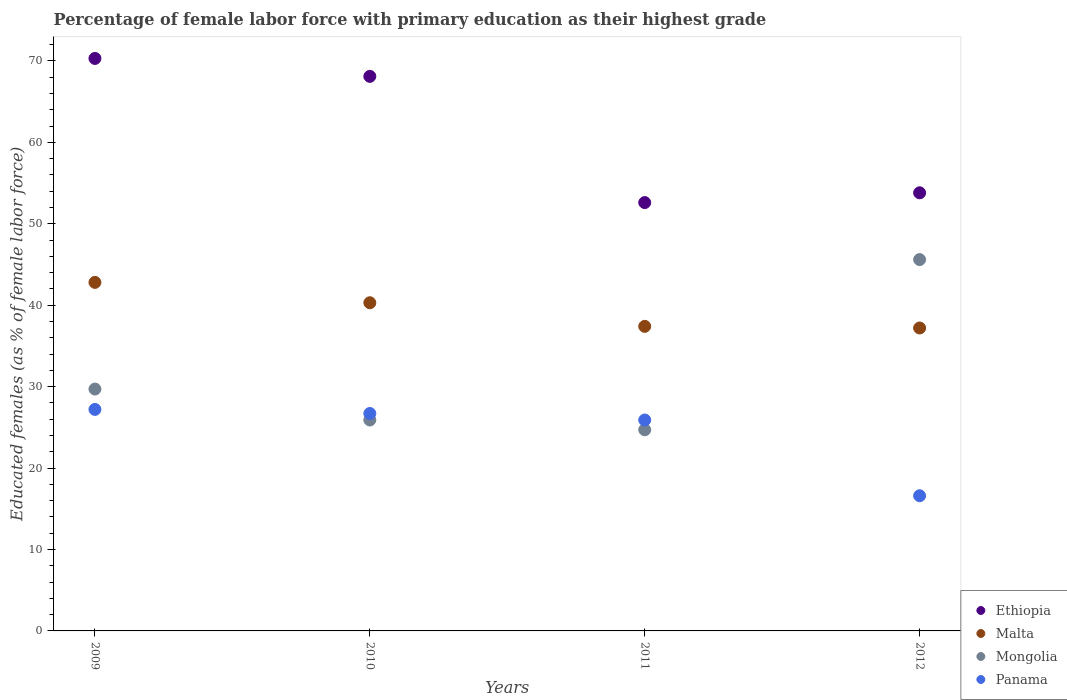What is the percentage of female labor force with primary education in Ethiopia in 2009?
Provide a succinct answer. 70.3. Across all years, what is the maximum percentage of female labor force with primary education in Panama?
Give a very brief answer. 27.2. Across all years, what is the minimum percentage of female labor force with primary education in Malta?
Keep it short and to the point. 37.2. In which year was the percentage of female labor force with primary education in Mongolia maximum?
Provide a succinct answer. 2012. What is the total percentage of female labor force with primary education in Ethiopia in the graph?
Your answer should be compact. 244.8. What is the difference between the percentage of female labor force with primary education in Malta in 2010 and that in 2011?
Your answer should be very brief. 2.9. What is the difference between the percentage of female labor force with primary education in Panama in 2011 and the percentage of female labor force with primary education in Malta in 2010?
Your answer should be very brief. -14.4. What is the average percentage of female labor force with primary education in Panama per year?
Give a very brief answer. 24.1. In the year 2011, what is the difference between the percentage of female labor force with primary education in Panama and percentage of female labor force with primary education in Ethiopia?
Offer a terse response. -26.7. In how many years, is the percentage of female labor force with primary education in Panama greater than 14 %?
Give a very brief answer. 4. What is the ratio of the percentage of female labor force with primary education in Mongolia in 2009 to that in 2011?
Your answer should be compact. 1.2. Is the percentage of female labor force with primary education in Panama in 2010 less than that in 2011?
Offer a very short reply. No. Is the difference between the percentage of female labor force with primary education in Panama in 2010 and 2012 greater than the difference between the percentage of female labor force with primary education in Ethiopia in 2010 and 2012?
Your answer should be very brief. No. What is the difference between the highest and the second highest percentage of female labor force with primary education in Ethiopia?
Offer a terse response. 2.2. What is the difference between the highest and the lowest percentage of female labor force with primary education in Panama?
Provide a short and direct response. 10.6. Is it the case that in every year, the sum of the percentage of female labor force with primary education in Mongolia and percentage of female labor force with primary education in Ethiopia  is greater than the sum of percentage of female labor force with primary education in Malta and percentage of female labor force with primary education in Panama?
Your answer should be very brief. No. Is it the case that in every year, the sum of the percentage of female labor force with primary education in Mongolia and percentage of female labor force with primary education in Panama  is greater than the percentage of female labor force with primary education in Malta?
Ensure brevity in your answer.  Yes. Does the percentage of female labor force with primary education in Panama monotonically increase over the years?
Keep it short and to the point. No. Is the percentage of female labor force with primary education in Panama strictly less than the percentage of female labor force with primary education in Mongolia over the years?
Provide a short and direct response. No. How many dotlines are there?
Your response must be concise. 4. How many years are there in the graph?
Your response must be concise. 4. Are the values on the major ticks of Y-axis written in scientific E-notation?
Your answer should be very brief. No. Does the graph contain grids?
Make the answer very short. No. How are the legend labels stacked?
Make the answer very short. Vertical. What is the title of the graph?
Make the answer very short. Percentage of female labor force with primary education as their highest grade. Does "Benin" appear as one of the legend labels in the graph?
Provide a succinct answer. No. What is the label or title of the Y-axis?
Keep it short and to the point. Educated females (as % of female labor force). What is the Educated females (as % of female labor force) in Ethiopia in 2009?
Make the answer very short. 70.3. What is the Educated females (as % of female labor force) in Malta in 2009?
Your answer should be very brief. 42.8. What is the Educated females (as % of female labor force) in Mongolia in 2009?
Keep it short and to the point. 29.7. What is the Educated females (as % of female labor force) in Panama in 2009?
Offer a terse response. 27.2. What is the Educated females (as % of female labor force) of Ethiopia in 2010?
Your response must be concise. 68.1. What is the Educated females (as % of female labor force) of Malta in 2010?
Provide a short and direct response. 40.3. What is the Educated females (as % of female labor force) of Mongolia in 2010?
Your answer should be compact. 25.9. What is the Educated females (as % of female labor force) in Panama in 2010?
Offer a very short reply. 26.7. What is the Educated females (as % of female labor force) in Ethiopia in 2011?
Offer a terse response. 52.6. What is the Educated females (as % of female labor force) of Malta in 2011?
Your response must be concise. 37.4. What is the Educated females (as % of female labor force) of Mongolia in 2011?
Ensure brevity in your answer.  24.7. What is the Educated females (as % of female labor force) of Panama in 2011?
Your answer should be very brief. 25.9. What is the Educated females (as % of female labor force) in Ethiopia in 2012?
Offer a very short reply. 53.8. What is the Educated females (as % of female labor force) in Malta in 2012?
Provide a succinct answer. 37.2. What is the Educated females (as % of female labor force) of Mongolia in 2012?
Offer a terse response. 45.6. What is the Educated females (as % of female labor force) in Panama in 2012?
Your answer should be compact. 16.6. Across all years, what is the maximum Educated females (as % of female labor force) of Ethiopia?
Give a very brief answer. 70.3. Across all years, what is the maximum Educated females (as % of female labor force) in Malta?
Keep it short and to the point. 42.8. Across all years, what is the maximum Educated females (as % of female labor force) in Mongolia?
Your answer should be very brief. 45.6. Across all years, what is the maximum Educated females (as % of female labor force) in Panama?
Your answer should be very brief. 27.2. Across all years, what is the minimum Educated females (as % of female labor force) of Ethiopia?
Offer a terse response. 52.6. Across all years, what is the minimum Educated females (as % of female labor force) of Malta?
Offer a terse response. 37.2. Across all years, what is the minimum Educated females (as % of female labor force) in Mongolia?
Your answer should be very brief. 24.7. Across all years, what is the minimum Educated females (as % of female labor force) in Panama?
Provide a short and direct response. 16.6. What is the total Educated females (as % of female labor force) in Ethiopia in the graph?
Provide a short and direct response. 244.8. What is the total Educated females (as % of female labor force) of Malta in the graph?
Make the answer very short. 157.7. What is the total Educated females (as % of female labor force) in Mongolia in the graph?
Offer a very short reply. 125.9. What is the total Educated females (as % of female labor force) of Panama in the graph?
Offer a terse response. 96.4. What is the difference between the Educated females (as % of female labor force) of Malta in 2009 and that in 2010?
Provide a succinct answer. 2.5. What is the difference between the Educated females (as % of female labor force) of Mongolia in 2009 and that in 2010?
Your answer should be very brief. 3.8. What is the difference between the Educated females (as % of female labor force) in Malta in 2009 and that in 2011?
Keep it short and to the point. 5.4. What is the difference between the Educated females (as % of female labor force) of Mongolia in 2009 and that in 2011?
Provide a succinct answer. 5. What is the difference between the Educated females (as % of female labor force) of Panama in 2009 and that in 2011?
Provide a short and direct response. 1.3. What is the difference between the Educated females (as % of female labor force) of Mongolia in 2009 and that in 2012?
Your answer should be very brief. -15.9. What is the difference between the Educated females (as % of female labor force) in Panama in 2009 and that in 2012?
Provide a succinct answer. 10.6. What is the difference between the Educated females (as % of female labor force) in Ethiopia in 2010 and that in 2011?
Your response must be concise. 15.5. What is the difference between the Educated females (as % of female labor force) of Malta in 2010 and that in 2011?
Make the answer very short. 2.9. What is the difference between the Educated females (as % of female labor force) of Ethiopia in 2010 and that in 2012?
Give a very brief answer. 14.3. What is the difference between the Educated females (as % of female labor force) in Malta in 2010 and that in 2012?
Offer a terse response. 3.1. What is the difference between the Educated females (as % of female labor force) of Mongolia in 2010 and that in 2012?
Offer a very short reply. -19.7. What is the difference between the Educated females (as % of female labor force) in Ethiopia in 2011 and that in 2012?
Keep it short and to the point. -1.2. What is the difference between the Educated females (as % of female labor force) in Malta in 2011 and that in 2012?
Provide a short and direct response. 0.2. What is the difference between the Educated females (as % of female labor force) in Mongolia in 2011 and that in 2012?
Ensure brevity in your answer.  -20.9. What is the difference between the Educated females (as % of female labor force) of Panama in 2011 and that in 2012?
Keep it short and to the point. 9.3. What is the difference between the Educated females (as % of female labor force) in Ethiopia in 2009 and the Educated females (as % of female labor force) in Mongolia in 2010?
Your answer should be very brief. 44.4. What is the difference between the Educated females (as % of female labor force) of Ethiopia in 2009 and the Educated females (as % of female labor force) of Panama in 2010?
Keep it short and to the point. 43.6. What is the difference between the Educated females (as % of female labor force) in Mongolia in 2009 and the Educated females (as % of female labor force) in Panama in 2010?
Your answer should be very brief. 3. What is the difference between the Educated females (as % of female labor force) in Ethiopia in 2009 and the Educated females (as % of female labor force) in Malta in 2011?
Make the answer very short. 32.9. What is the difference between the Educated females (as % of female labor force) of Ethiopia in 2009 and the Educated females (as % of female labor force) of Mongolia in 2011?
Make the answer very short. 45.6. What is the difference between the Educated females (as % of female labor force) of Ethiopia in 2009 and the Educated females (as % of female labor force) of Panama in 2011?
Offer a very short reply. 44.4. What is the difference between the Educated females (as % of female labor force) in Malta in 2009 and the Educated females (as % of female labor force) in Panama in 2011?
Offer a very short reply. 16.9. What is the difference between the Educated females (as % of female labor force) of Mongolia in 2009 and the Educated females (as % of female labor force) of Panama in 2011?
Your answer should be compact. 3.8. What is the difference between the Educated females (as % of female labor force) in Ethiopia in 2009 and the Educated females (as % of female labor force) in Malta in 2012?
Provide a succinct answer. 33.1. What is the difference between the Educated females (as % of female labor force) in Ethiopia in 2009 and the Educated females (as % of female labor force) in Mongolia in 2012?
Your response must be concise. 24.7. What is the difference between the Educated females (as % of female labor force) in Ethiopia in 2009 and the Educated females (as % of female labor force) in Panama in 2012?
Your answer should be very brief. 53.7. What is the difference between the Educated females (as % of female labor force) in Malta in 2009 and the Educated females (as % of female labor force) in Panama in 2012?
Provide a short and direct response. 26.2. What is the difference between the Educated females (as % of female labor force) in Mongolia in 2009 and the Educated females (as % of female labor force) in Panama in 2012?
Ensure brevity in your answer.  13.1. What is the difference between the Educated females (as % of female labor force) in Ethiopia in 2010 and the Educated females (as % of female labor force) in Malta in 2011?
Provide a succinct answer. 30.7. What is the difference between the Educated females (as % of female labor force) of Ethiopia in 2010 and the Educated females (as % of female labor force) of Mongolia in 2011?
Make the answer very short. 43.4. What is the difference between the Educated females (as % of female labor force) of Ethiopia in 2010 and the Educated females (as % of female labor force) of Panama in 2011?
Keep it short and to the point. 42.2. What is the difference between the Educated females (as % of female labor force) of Malta in 2010 and the Educated females (as % of female labor force) of Mongolia in 2011?
Give a very brief answer. 15.6. What is the difference between the Educated females (as % of female labor force) in Malta in 2010 and the Educated females (as % of female labor force) in Panama in 2011?
Provide a succinct answer. 14.4. What is the difference between the Educated females (as % of female labor force) of Mongolia in 2010 and the Educated females (as % of female labor force) of Panama in 2011?
Make the answer very short. 0. What is the difference between the Educated females (as % of female labor force) of Ethiopia in 2010 and the Educated females (as % of female labor force) of Malta in 2012?
Your answer should be compact. 30.9. What is the difference between the Educated females (as % of female labor force) of Ethiopia in 2010 and the Educated females (as % of female labor force) of Mongolia in 2012?
Offer a very short reply. 22.5. What is the difference between the Educated females (as % of female labor force) in Ethiopia in 2010 and the Educated females (as % of female labor force) in Panama in 2012?
Offer a very short reply. 51.5. What is the difference between the Educated females (as % of female labor force) of Malta in 2010 and the Educated females (as % of female labor force) of Panama in 2012?
Your answer should be compact. 23.7. What is the difference between the Educated females (as % of female labor force) of Mongolia in 2010 and the Educated females (as % of female labor force) of Panama in 2012?
Your response must be concise. 9.3. What is the difference between the Educated females (as % of female labor force) in Ethiopia in 2011 and the Educated females (as % of female labor force) in Malta in 2012?
Give a very brief answer. 15.4. What is the difference between the Educated females (as % of female labor force) in Ethiopia in 2011 and the Educated females (as % of female labor force) in Panama in 2012?
Offer a very short reply. 36. What is the difference between the Educated females (as % of female labor force) of Malta in 2011 and the Educated females (as % of female labor force) of Panama in 2012?
Offer a very short reply. 20.8. What is the average Educated females (as % of female labor force) of Ethiopia per year?
Ensure brevity in your answer.  61.2. What is the average Educated females (as % of female labor force) in Malta per year?
Your response must be concise. 39.42. What is the average Educated females (as % of female labor force) in Mongolia per year?
Give a very brief answer. 31.48. What is the average Educated females (as % of female labor force) in Panama per year?
Your answer should be compact. 24.1. In the year 2009, what is the difference between the Educated females (as % of female labor force) in Ethiopia and Educated females (as % of female labor force) in Malta?
Offer a terse response. 27.5. In the year 2009, what is the difference between the Educated females (as % of female labor force) of Ethiopia and Educated females (as % of female labor force) of Mongolia?
Offer a very short reply. 40.6. In the year 2009, what is the difference between the Educated females (as % of female labor force) of Ethiopia and Educated females (as % of female labor force) of Panama?
Offer a terse response. 43.1. In the year 2009, what is the difference between the Educated females (as % of female labor force) of Malta and Educated females (as % of female labor force) of Panama?
Your response must be concise. 15.6. In the year 2009, what is the difference between the Educated females (as % of female labor force) of Mongolia and Educated females (as % of female labor force) of Panama?
Keep it short and to the point. 2.5. In the year 2010, what is the difference between the Educated females (as % of female labor force) of Ethiopia and Educated females (as % of female labor force) of Malta?
Your answer should be very brief. 27.8. In the year 2010, what is the difference between the Educated females (as % of female labor force) in Ethiopia and Educated females (as % of female labor force) in Mongolia?
Ensure brevity in your answer.  42.2. In the year 2010, what is the difference between the Educated females (as % of female labor force) in Ethiopia and Educated females (as % of female labor force) in Panama?
Offer a terse response. 41.4. In the year 2010, what is the difference between the Educated females (as % of female labor force) of Malta and Educated females (as % of female labor force) of Mongolia?
Your response must be concise. 14.4. In the year 2010, what is the difference between the Educated females (as % of female labor force) of Malta and Educated females (as % of female labor force) of Panama?
Your answer should be very brief. 13.6. In the year 2011, what is the difference between the Educated females (as % of female labor force) of Ethiopia and Educated females (as % of female labor force) of Malta?
Give a very brief answer. 15.2. In the year 2011, what is the difference between the Educated females (as % of female labor force) in Ethiopia and Educated females (as % of female labor force) in Mongolia?
Your answer should be very brief. 27.9. In the year 2011, what is the difference between the Educated females (as % of female labor force) of Ethiopia and Educated females (as % of female labor force) of Panama?
Your answer should be very brief. 26.7. In the year 2011, what is the difference between the Educated females (as % of female labor force) of Malta and Educated females (as % of female labor force) of Panama?
Offer a terse response. 11.5. In the year 2011, what is the difference between the Educated females (as % of female labor force) of Mongolia and Educated females (as % of female labor force) of Panama?
Give a very brief answer. -1.2. In the year 2012, what is the difference between the Educated females (as % of female labor force) of Ethiopia and Educated females (as % of female labor force) of Panama?
Offer a terse response. 37.2. In the year 2012, what is the difference between the Educated females (as % of female labor force) of Malta and Educated females (as % of female labor force) of Panama?
Provide a succinct answer. 20.6. What is the ratio of the Educated females (as % of female labor force) of Ethiopia in 2009 to that in 2010?
Your answer should be compact. 1.03. What is the ratio of the Educated females (as % of female labor force) in Malta in 2009 to that in 2010?
Provide a short and direct response. 1.06. What is the ratio of the Educated females (as % of female labor force) of Mongolia in 2009 to that in 2010?
Provide a succinct answer. 1.15. What is the ratio of the Educated females (as % of female labor force) in Panama in 2009 to that in 2010?
Your answer should be very brief. 1.02. What is the ratio of the Educated females (as % of female labor force) in Ethiopia in 2009 to that in 2011?
Make the answer very short. 1.34. What is the ratio of the Educated females (as % of female labor force) in Malta in 2009 to that in 2011?
Your answer should be compact. 1.14. What is the ratio of the Educated females (as % of female labor force) of Mongolia in 2009 to that in 2011?
Offer a terse response. 1.2. What is the ratio of the Educated females (as % of female labor force) of Panama in 2009 to that in 2011?
Your answer should be compact. 1.05. What is the ratio of the Educated females (as % of female labor force) of Ethiopia in 2009 to that in 2012?
Ensure brevity in your answer.  1.31. What is the ratio of the Educated females (as % of female labor force) in Malta in 2009 to that in 2012?
Give a very brief answer. 1.15. What is the ratio of the Educated females (as % of female labor force) in Mongolia in 2009 to that in 2012?
Ensure brevity in your answer.  0.65. What is the ratio of the Educated females (as % of female labor force) of Panama in 2009 to that in 2012?
Ensure brevity in your answer.  1.64. What is the ratio of the Educated females (as % of female labor force) in Ethiopia in 2010 to that in 2011?
Make the answer very short. 1.29. What is the ratio of the Educated females (as % of female labor force) in Malta in 2010 to that in 2011?
Offer a very short reply. 1.08. What is the ratio of the Educated females (as % of female labor force) in Mongolia in 2010 to that in 2011?
Keep it short and to the point. 1.05. What is the ratio of the Educated females (as % of female labor force) in Panama in 2010 to that in 2011?
Give a very brief answer. 1.03. What is the ratio of the Educated females (as % of female labor force) in Ethiopia in 2010 to that in 2012?
Your answer should be very brief. 1.27. What is the ratio of the Educated females (as % of female labor force) of Mongolia in 2010 to that in 2012?
Make the answer very short. 0.57. What is the ratio of the Educated females (as % of female labor force) in Panama in 2010 to that in 2012?
Offer a terse response. 1.61. What is the ratio of the Educated females (as % of female labor force) of Ethiopia in 2011 to that in 2012?
Make the answer very short. 0.98. What is the ratio of the Educated females (as % of female labor force) of Malta in 2011 to that in 2012?
Your answer should be very brief. 1.01. What is the ratio of the Educated females (as % of female labor force) in Mongolia in 2011 to that in 2012?
Your answer should be compact. 0.54. What is the ratio of the Educated females (as % of female labor force) of Panama in 2011 to that in 2012?
Your answer should be very brief. 1.56. What is the difference between the highest and the second highest Educated females (as % of female labor force) in Ethiopia?
Provide a short and direct response. 2.2. What is the difference between the highest and the second highest Educated females (as % of female labor force) in Malta?
Offer a terse response. 2.5. What is the difference between the highest and the second highest Educated females (as % of female labor force) of Mongolia?
Your response must be concise. 15.9. What is the difference between the highest and the lowest Educated females (as % of female labor force) of Ethiopia?
Your answer should be very brief. 17.7. What is the difference between the highest and the lowest Educated females (as % of female labor force) in Mongolia?
Your response must be concise. 20.9. What is the difference between the highest and the lowest Educated females (as % of female labor force) in Panama?
Ensure brevity in your answer.  10.6. 